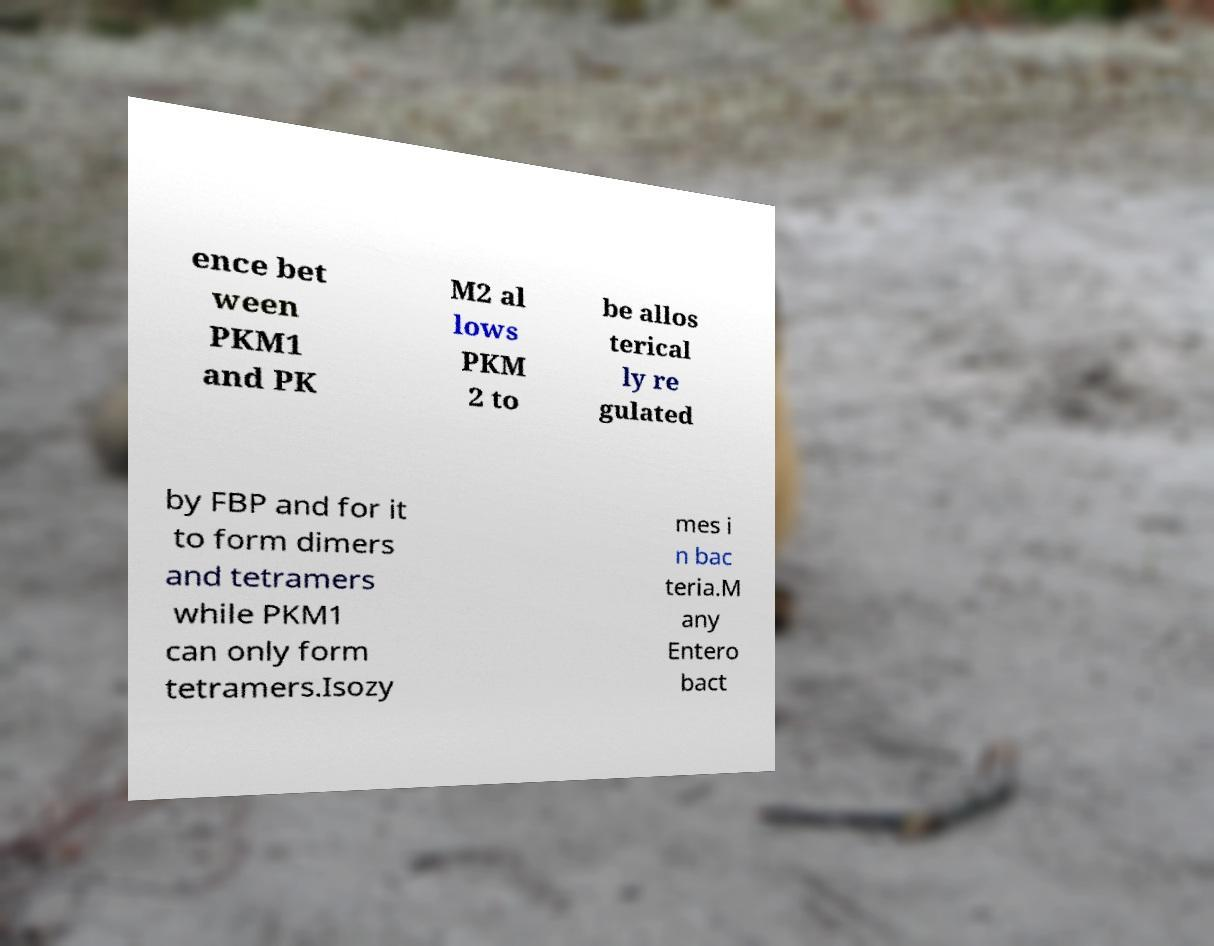I need the written content from this picture converted into text. Can you do that? ence bet ween PKM1 and PK M2 al lows PKM 2 to be allos terical ly re gulated by FBP and for it to form dimers and tetramers while PKM1 can only form tetramers.Isozy mes i n bac teria.M any Entero bact 